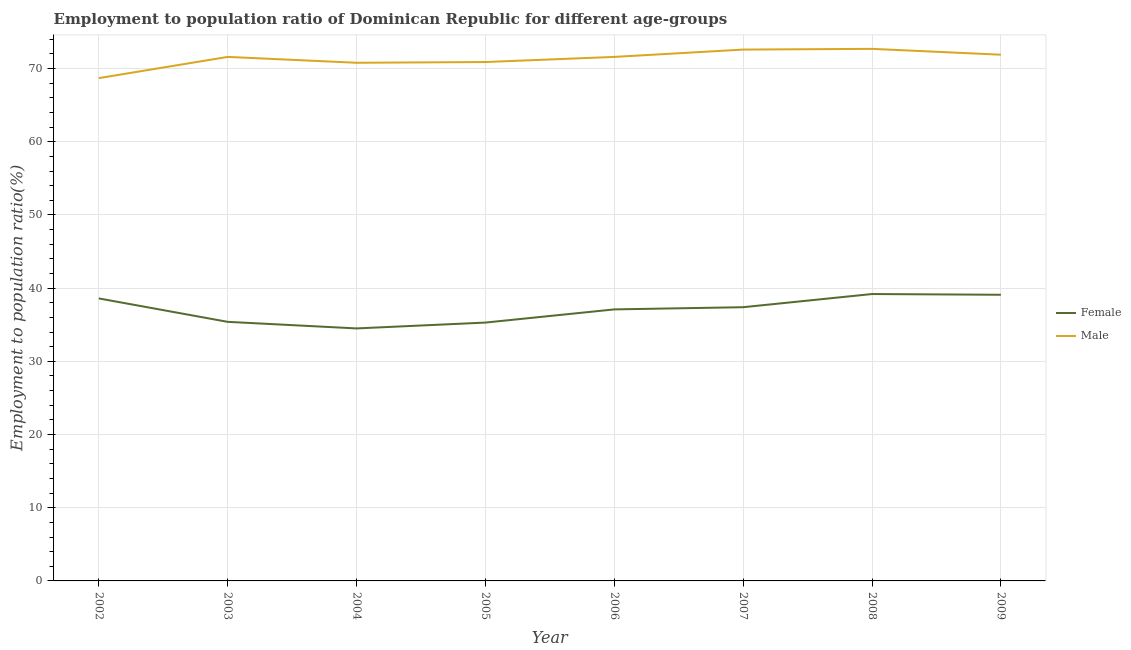How many different coloured lines are there?
Provide a short and direct response. 2. What is the employment to population ratio(female) in 2007?
Your answer should be very brief. 37.4. Across all years, what is the maximum employment to population ratio(male)?
Your response must be concise. 72.7. Across all years, what is the minimum employment to population ratio(male)?
Your response must be concise. 68.7. What is the total employment to population ratio(female) in the graph?
Give a very brief answer. 296.6. What is the difference between the employment to population ratio(female) in 2003 and that in 2008?
Your response must be concise. -3.8. What is the difference between the employment to population ratio(male) in 2009 and the employment to population ratio(female) in 2005?
Offer a terse response. 36.6. What is the average employment to population ratio(male) per year?
Offer a terse response. 71.35. In the year 2003, what is the difference between the employment to population ratio(male) and employment to population ratio(female)?
Offer a very short reply. 36.2. In how many years, is the employment to population ratio(male) greater than 66 %?
Your answer should be compact. 8. What is the ratio of the employment to population ratio(male) in 2002 to that in 2007?
Provide a succinct answer. 0.95. Is the difference between the employment to population ratio(female) in 2002 and 2004 greater than the difference between the employment to population ratio(male) in 2002 and 2004?
Your answer should be compact. Yes. What is the difference between the highest and the second highest employment to population ratio(female)?
Your answer should be compact. 0.1. What is the difference between the highest and the lowest employment to population ratio(male)?
Provide a short and direct response. 4. Is the employment to population ratio(female) strictly greater than the employment to population ratio(male) over the years?
Provide a short and direct response. No. How many lines are there?
Your answer should be very brief. 2. How many years are there in the graph?
Ensure brevity in your answer.  8. Does the graph contain any zero values?
Your response must be concise. No. Does the graph contain grids?
Provide a short and direct response. Yes. What is the title of the graph?
Provide a succinct answer. Employment to population ratio of Dominican Republic for different age-groups. Does "Official aid received" appear as one of the legend labels in the graph?
Make the answer very short. No. What is the Employment to population ratio(%) of Female in 2002?
Provide a succinct answer. 38.6. What is the Employment to population ratio(%) of Male in 2002?
Ensure brevity in your answer.  68.7. What is the Employment to population ratio(%) in Female in 2003?
Give a very brief answer. 35.4. What is the Employment to population ratio(%) in Male in 2003?
Your answer should be compact. 71.6. What is the Employment to population ratio(%) in Female in 2004?
Offer a terse response. 34.5. What is the Employment to population ratio(%) of Male in 2004?
Your answer should be compact. 70.8. What is the Employment to population ratio(%) of Female in 2005?
Your answer should be compact. 35.3. What is the Employment to population ratio(%) of Male in 2005?
Offer a very short reply. 70.9. What is the Employment to population ratio(%) in Female in 2006?
Provide a short and direct response. 37.1. What is the Employment to population ratio(%) in Male in 2006?
Offer a terse response. 71.6. What is the Employment to population ratio(%) in Female in 2007?
Provide a short and direct response. 37.4. What is the Employment to population ratio(%) of Male in 2007?
Ensure brevity in your answer.  72.6. What is the Employment to population ratio(%) of Female in 2008?
Offer a very short reply. 39.2. What is the Employment to population ratio(%) of Male in 2008?
Provide a succinct answer. 72.7. What is the Employment to population ratio(%) in Female in 2009?
Keep it short and to the point. 39.1. What is the Employment to population ratio(%) in Male in 2009?
Your response must be concise. 71.9. Across all years, what is the maximum Employment to population ratio(%) in Female?
Make the answer very short. 39.2. Across all years, what is the maximum Employment to population ratio(%) in Male?
Provide a short and direct response. 72.7. Across all years, what is the minimum Employment to population ratio(%) in Female?
Offer a very short reply. 34.5. Across all years, what is the minimum Employment to population ratio(%) of Male?
Your answer should be compact. 68.7. What is the total Employment to population ratio(%) in Female in the graph?
Ensure brevity in your answer.  296.6. What is the total Employment to population ratio(%) of Male in the graph?
Keep it short and to the point. 570.8. What is the difference between the Employment to population ratio(%) in Female in 2002 and that in 2003?
Make the answer very short. 3.2. What is the difference between the Employment to population ratio(%) in Male in 2002 and that in 2003?
Give a very brief answer. -2.9. What is the difference between the Employment to population ratio(%) of Female in 2002 and that in 2004?
Provide a succinct answer. 4.1. What is the difference between the Employment to population ratio(%) of Female in 2002 and that in 2005?
Make the answer very short. 3.3. What is the difference between the Employment to population ratio(%) in Male in 2002 and that in 2005?
Provide a short and direct response. -2.2. What is the difference between the Employment to population ratio(%) of Male in 2002 and that in 2006?
Provide a succinct answer. -2.9. What is the difference between the Employment to population ratio(%) in Female in 2002 and that in 2008?
Your answer should be compact. -0.6. What is the difference between the Employment to population ratio(%) in Female in 2002 and that in 2009?
Give a very brief answer. -0.5. What is the difference between the Employment to population ratio(%) in Male in 2002 and that in 2009?
Ensure brevity in your answer.  -3.2. What is the difference between the Employment to population ratio(%) of Female in 2003 and that in 2007?
Make the answer very short. -2. What is the difference between the Employment to population ratio(%) in Male in 2003 and that in 2007?
Provide a short and direct response. -1. What is the difference between the Employment to population ratio(%) of Male in 2003 and that in 2008?
Make the answer very short. -1.1. What is the difference between the Employment to population ratio(%) of Male in 2003 and that in 2009?
Your answer should be compact. -0.3. What is the difference between the Employment to population ratio(%) in Female in 2004 and that in 2009?
Give a very brief answer. -4.6. What is the difference between the Employment to population ratio(%) of Male in 2004 and that in 2009?
Offer a terse response. -1.1. What is the difference between the Employment to population ratio(%) in Female in 2005 and that in 2007?
Your answer should be compact. -2.1. What is the difference between the Employment to population ratio(%) of Male in 2005 and that in 2009?
Give a very brief answer. -1. What is the difference between the Employment to population ratio(%) in Male in 2006 and that in 2007?
Ensure brevity in your answer.  -1. What is the difference between the Employment to population ratio(%) in Male in 2006 and that in 2008?
Provide a short and direct response. -1.1. What is the difference between the Employment to population ratio(%) of Female in 2006 and that in 2009?
Your answer should be very brief. -2. What is the difference between the Employment to population ratio(%) of Male in 2007 and that in 2008?
Ensure brevity in your answer.  -0.1. What is the difference between the Employment to population ratio(%) of Female in 2008 and that in 2009?
Ensure brevity in your answer.  0.1. What is the difference between the Employment to population ratio(%) in Male in 2008 and that in 2009?
Offer a very short reply. 0.8. What is the difference between the Employment to population ratio(%) in Female in 2002 and the Employment to population ratio(%) in Male in 2003?
Ensure brevity in your answer.  -33. What is the difference between the Employment to population ratio(%) in Female in 2002 and the Employment to population ratio(%) in Male in 2004?
Give a very brief answer. -32.2. What is the difference between the Employment to population ratio(%) of Female in 2002 and the Employment to population ratio(%) of Male in 2005?
Provide a short and direct response. -32.3. What is the difference between the Employment to population ratio(%) of Female in 2002 and the Employment to population ratio(%) of Male in 2006?
Give a very brief answer. -33. What is the difference between the Employment to population ratio(%) of Female in 2002 and the Employment to population ratio(%) of Male in 2007?
Your response must be concise. -34. What is the difference between the Employment to population ratio(%) of Female in 2002 and the Employment to population ratio(%) of Male in 2008?
Make the answer very short. -34.1. What is the difference between the Employment to population ratio(%) in Female in 2002 and the Employment to population ratio(%) in Male in 2009?
Provide a succinct answer. -33.3. What is the difference between the Employment to population ratio(%) of Female in 2003 and the Employment to population ratio(%) of Male in 2004?
Give a very brief answer. -35.4. What is the difference between the Employment to population ratio(%) of Female in 2003 and the Employment to population ratio(%) of Male in 2005?
Your answer should be very brief. -35.5. What is the difference between the Employment to population ratio(%) in Female in 2003 and the Employment to population ratio(%) in Male in 2006?
Your answer should be very brief. -36.2. What is the difference between the Employment to population ratio(%) in Female in 2003 and the Employment to population ratio(%) in Male in 2007?
Offer a very short reply. -37.2. What is the difference between the Employment to population ratio(%) of Female in 2003 and the Employment to population ratio(%) of Male in 2008?
Give a very brief answer. -37.3. What is the difference between the Employment to population ratio(%) of Female in 2003 and the Employment to population ratio(%) of Male in 2009?
Give a very brief answer. -36.5. What is the difference between the Employment to population ratio(%) of Female in 2004 and the Employment to population ratio(%) of Male in 2005?
Keep it short and to the point. -36.4. What is the difference between the Employment to population ratio(%) of Female in 2004 and the Employment to population ratio(%) of Male in 2006?
Make the answer very short. -37.1. What is the difference between the Employment to population ratio(%) in Female in 2004 and the Employment to population ratio(%) in Male in 2007?
Give a very brief answer. -38.1. What is the difference between the Employment to population ratio(%) of Female in 2004 and the Employment to population ratio(%) of Male in 2008?
Make the answer very short. -38.2. What is the difference between the Employment to population ratio(%) of Female in 2004 and the Employment to population ratio(%) of Male in 2009?
Keep it short and to the point. -37.4. What is the difference between the Employment to population ratio(%) of Female in 2005 and the Employment to population ratio(%) of Male in 2006?
Your answer should be compact. -36.3. What is the difference between the Employment to population ratio(%) of Female in 2005 and the Employment to population ratio(%) of Male in 2007?
Give a very brief answer. -37.3. What is the difference between the Employment to population ratio(%) of Female in 2005 and the Employment to population ratio(%) of Male in 2008?
Your answer should be very brief. -37.4. What is the difference between the Employment to population ratio(%) in Female in 2005 and the Employment to population ratio(%) in Male in 2009?
Provide a short and direct response. -36.6. What is the difference between the Employment to population ratio(%) of Female in 2006 and the Employment to population ratio(%) of Male in 2007?
Make the answer very short. -35.5. What is the difference between the Employment to population ratio(%) of Female in 2006 and the Employment to population ratio(%) of Male in 2008?
Your answer should be very brief. -35.6. What is the difference between the Employment to population ratio(%) in Female in 2006 and the Employment to population ratio(%) in Male in 2009?
Offer a very short reply. -34.8. What is the difference between the Employment to population ratio(%) of Female in 2007 and the Employment to population ratio(%) of Male in 2008?
Provide a succinct answer. -35.3. What is the difference between the Employment to population ratio(%) of Female in 2007 and the Employment to population ratio(%) of Male in 2009?
Give a very brief answer. -34.5. What is the difference between the Employment to population ratio(%) of Female in 2008 and the Employment to population ratio(%) of Male in 2009?
Ensure brevity in your answer.  -32.7. What is the average Employment to population ratio(%) in Female per year?
Offer a very short reply. 37.08. What is the average Employment to population ratio(%) in Male per year?
Your answer should be very brief. 71.35. In the year 2002, what is the difference between the Employment to population ratio(%) of Female and Employment to population ratio(%) of Male?
Your response must be concise. -30.1. In the year 2003, what is the difference between the Employment to population ratio(%) in Female and Employment to population ratio(%) in Male?
Provide a short and direct response. -36.2. In the year 2004, what is the difference between the Employment to population ratio(%) of Female and Employment to population ratio(%) of Male?
Offer a very short reply. -36.3. In the year 2005, what is the difference between the Employment to population ratio(%) in Female and Employment to population ratio(%) in Male?
Ensure brevity in your answer.  -35.6. In the year 2006, what is the difference between the Employment to population ratio(%) in Female and Employment to population ratio(%) in Male?
Your response must be concise. -34.5. In the year 2007, what is the difference between the Employment to population ratio(%) of Female and Employment to population ratio(%) of Male?
Your response must be concise. -35.2. In the year 2008, what is the difference between the Employment to population ratio(%) in Female and Employment to population ratio(%) in Male?
Offer a terse response. -33.5. In the year 2009, what is the difference between the Employment to population ratio(%) in Female and Employment to population ratio(%) in Male?
Keep it short and to the point. -32.8. What is the ratio of the Employment to population ratio(%) of Female in 2002 to that in 2003?
Offer a terse response. 1.09. What is the ratio of the Employment to population ratio(%) of Male in 2002 to that in 2003?
Make the answer very short. 0.96. What is the ratio of the Employment to population ratio(%) of Female in 2002 to that in 2004?
Ensure brevity in your answer.  1.12. What is the ratio of the Employment to population ratio(%) in Male in 2002 to that in 2004?
Ensure brevity in your answer.  0.97. What is the ratio of the Employment to population ratio(%) in Female in 2002 to that in 2005?
Offer a very short reply. 1.09. What is the ratio of the Employment to population ratio(%) of Male in 2002 to that in 2005?
Make the answer very short. 0.97. What is the ratio of the Employment to population ratio(%) of Female in 2002 to that in 2006?
Your answer should be compact. 1.04. What is the ratio of the Employment to population ratio(%) in Male in 2002 to that in 2006?
Provide a succinct answer. 0.96. What is the ratio of the Employment to population ratio(%) of Female in 2002 to that in 2007?
Provide a short and direct response. 1.03. What is the ratio of the Employment to population ratio(%) in Male in 2002 to that in 2007?
Your answer should be compact. 0.95. What is the ratio of the Employment to population ratio(%) in Female in 2002 to that in 2008?
Ensure brevity in your answer.  0.98. What is the ratio of the Employment to population ratio(%) of Male in 2002 to that in 2008?
Keep it short and to the point. 0.94. What is the ratio of the Employment to population ratio(%) in Female in 2002 to that in 2009?
Your answer should be compact. 0.99. What is the ratio of the Employment to population ratio(%) in Male in 2002 to that in 2009?
Offer a very short reply. 0.96. What is the ratio of the Employment to population ratio(%) of Female in 2003 to that in 2004?
Your response must be concise. 1.03. What is the ratio of the Employment to population ratio(%) in Male in 2003 to that in 2004?
Keep it short and to the point. 1.01. What is the ratio of the Employment to population ratio(%) in Male in 2003 to that in 2005?
Provide a succinct answer. 1.01. What is the ratio of the Employment to population ratio(%) of Female in 2003 to that in 2006?
Your answer should be very brief. 0.95. What is the ratio of the Employment to population ratio(%) in Female in 2003 to that in 2007?
Offer a terse response. 0.95. What is the ratio of the Employment to population ratio(%) in Male in 2003 to that in 2007?
Provide a short and direct response. 0.99. What is the ratio of the Employment to population ratio(%) of Female in 2003 to that in 2008?
Your response must be concise. 0.9. What is the ratio of the Employment to population ratio(%) of Male in 2003 to that in 2008?
Your response must be concise. 0.98. What is the ratio of the Employment to population ratio(%) in Female in 2003 to that in 2009?
Your answer should be very brief. 0.91. What is the ratio of the Employment to population ratio(%) in Female in 2004 to that in 2005?
Offer a terse response. 0.98. What is the ratio of the Employment to population ratio(%) in Male in 2004 to that in 2005?
Provide a short and direct response. 1. What is the ratio of the Employment to population ratio(%) of Female in 2004 to that in 2006?
Offer a terse response. 0.93. What is the ratio of the Employment to population ratio(%) in Male in 2004 to that in 2006?
Offer a very short reply. 0.99. What is the ratio of the Employment to population ratio(%) in Female in 2004 to that in 2007?
Your answer should be compact. 0.92. What is the ratio of the Employment to population ratio(%) of Male in 2004 to that in 2007?
Keep it short and to the point. 0.98. What is the ratio of the Employment to population ratio(%) in Female in 2004 to that in 2008?
Offer a very short reply. 0.88. What is the ratio of the Employment to population ratio(%) in Male in 2004 to that in 2008?
Give a very brief answer. 0.97. What is the ratio of the Employment to population ratio(%) in Female in 2004 to that in 2009?
Ensure brevity in your answer.  0.88. What is the ratio of the Employment to population ratio(%) in Male in 2004 to that in 2009?
Keep it short and to the point. 0.98. What is the ratio of the Employment to population ratio(%) in Female in 2005 to that in 2006?
Keep it short and to the point. 0.95. What is the ratio of the Employment to population ratio(%) of Male in 2005 to that in 2006?
Your answer should be very brief. 0.99. What is the ratio of the Employment to population ratio(%) of Female in 2005 to that in 2007?
Ensure brevity in your answer.  0.94. What is the ratio of the Employment to population ratio(%) of Male in 2005 to that in 2007?
Provide a succinct answer. 0.98. What is the ratio of the Employment to population ratio(%) in Female in 2005 to that in 2008?
Give a very brief answer. 0.9. What is the ratio of the Employment to population ratio(%) in Male in 2005 to that in 2008?
Keep it short and to the point. 0.98. What is the ratio of the Employment to population ratio(%) of Female in 2005 to that in 2009?
Offer a terse response. 0.9. What is the ratio of the Employment to population ratio(%) in Male in 2005 to that in 2009?
Ensure brevity in your answer.  0.99. What is the ratio of the Employment to population ratio(%) of Female in 2006 to that in 2007?
Offer a very short reply. 0.99. What is the ratio of the Employment to population ratio(%) in Male in 2006 to that in 2007?
Keep it short and to the point. 0.99. What is the ratio of the Employment to population ratio(%) of Female in 2006 to that in 2008?
Offer a terse response. 0.95. What is the ratio of the Employment to population ratio(%) of Male in 2006 to that in 2008?
Provide a short and direct response. 0.98. What is the ratio of the Employment to population ratio(%) of Female in 2006 to that in 2009?
Provide a succinct answer. 0.95. What is the ratio of the Employment to population ratio(%) of Female in 2007 to that in 2008?
Your answer should be very brief. 0.95. What is the ratio of the Employment to population ratio(%) in Male in 2007 to that in 2008?
Give a very brief answer. 1. What is the ratio of the Employment to population ratio(%) in Female in 2007 to that in 2009?
Offer a terse response. 0.96. What is the ratio of the Employment to population ratio(%) in Male in 2007 to that in 2009?
Ensure brevity in your answer.  1.01. What is the ratio of the Employment to population ratio(%) of Female in 2008 to that in 2009?
Your answer should be very brief. 1. What is the ratio of the Employment to population ratio(%) of Male in 2008 to that in 2009?
Keep it short and to the point. 1.01. 